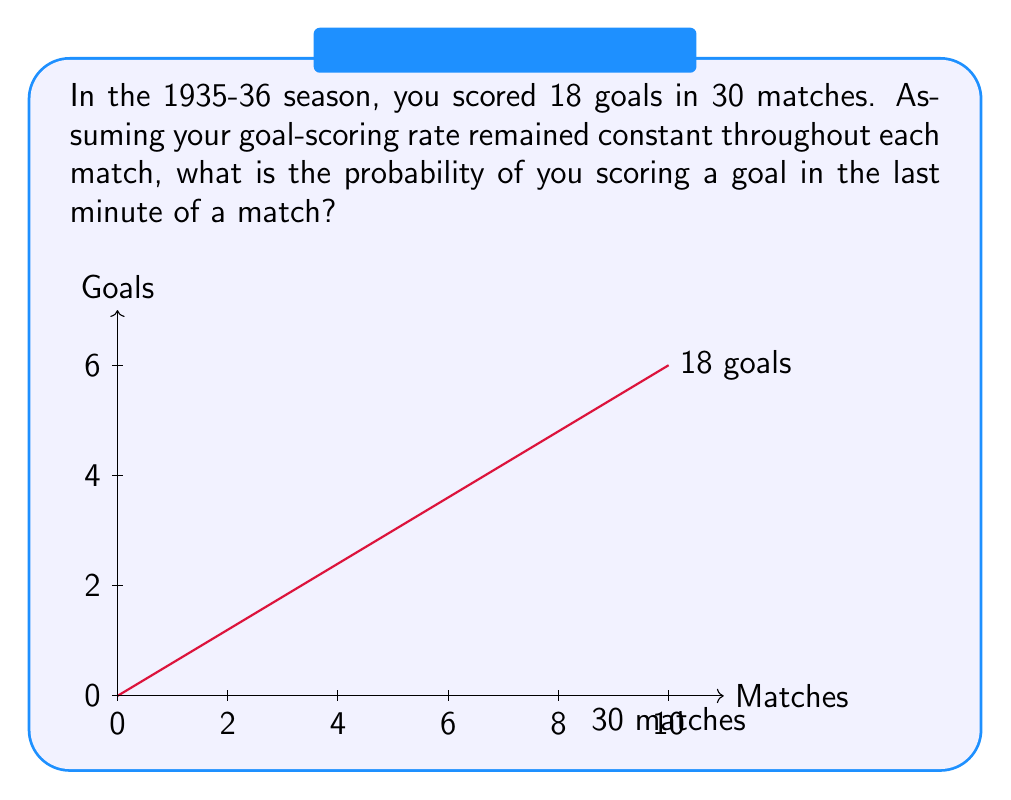Can you solve this math problem? Let's approach this step-by-step:

1) First, we need to calculate the average number of goals scored per match:
   $\frac{\text{Total goals}}{\text{Total matches}} = \frac{18}{30} = 0.6$ goals per match

2) Now, we need to find the probability of scoring in any given minute. Since there are 90 minutes in a football match:
   $\frac{\text{Goals per match}}{\text{Minutes per match}} = \frac{0.6}{90} = \frac{1}{150} = 0.00667$ goals per minute

3) This means that in any given minute, the probability of scoring is 0.00667.

4) The question asks for the probability of scoring in the last minute, which is just one specific minute. Therefore, the probability remains 0.00667.

5) To express this as a fraction:
   $\frac{1}{150}$

Note: This assumes that the goal-scoring rate is constant throughout the match, which may not be true in reality due to factors like fatigue or tactical changes.
Answer: $\frac{1}{150}$ 